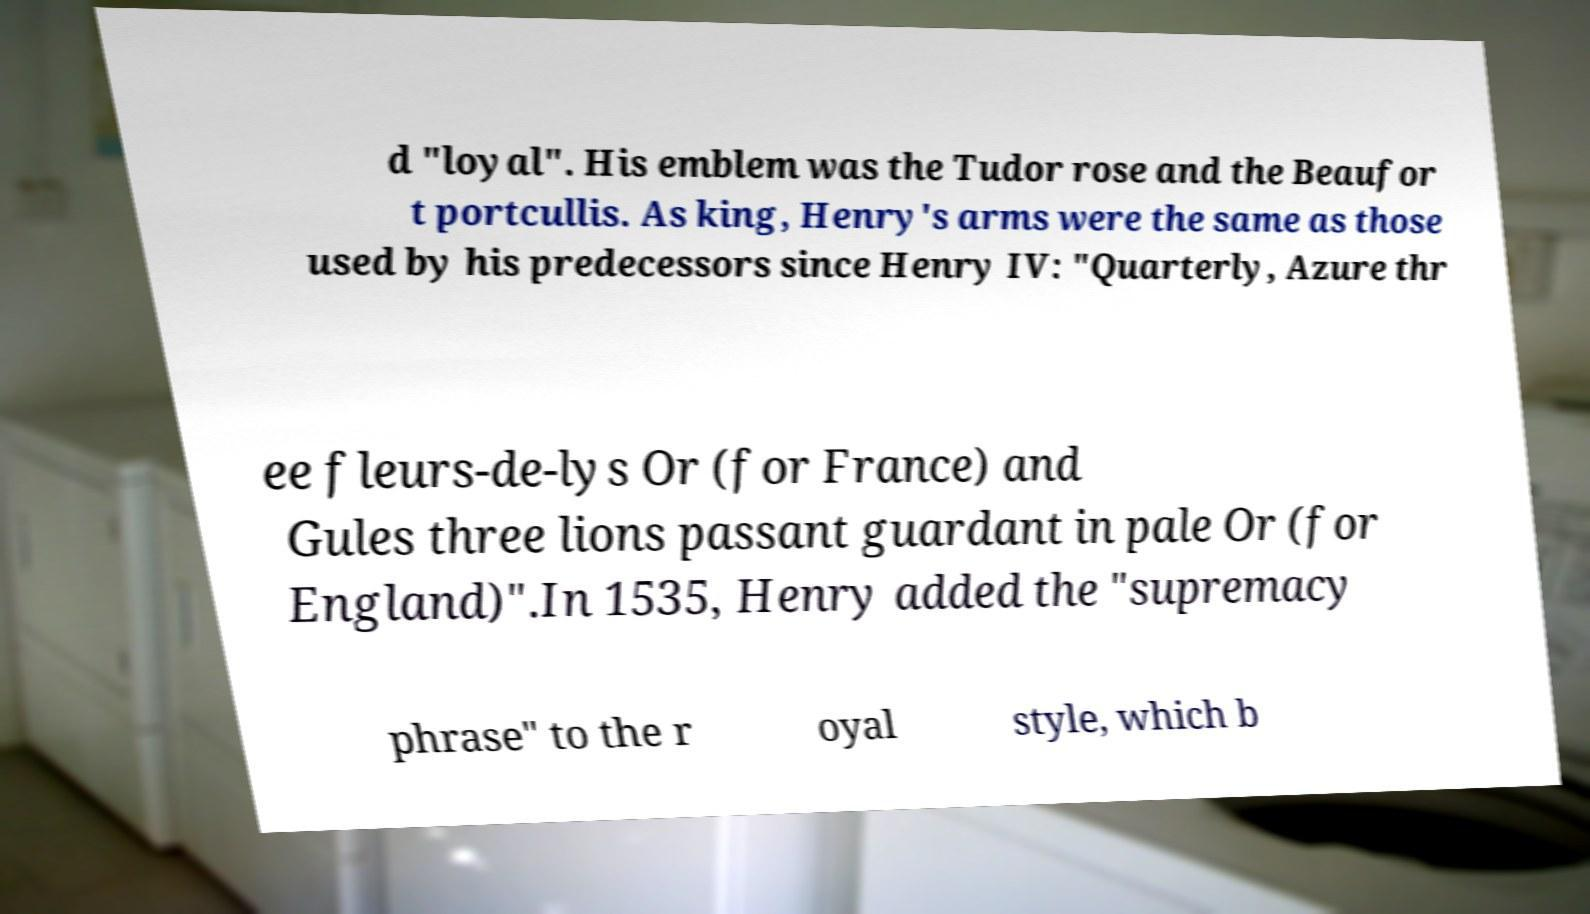There's text embedded in this image that I need extracted. Can you transcribe it verbatim? d "loyal". His emblem was the Tudor rose and the Beaufor t portcullis. As king, Henry's arms were the same as those used by his predecessors since Henry IV: "Quarterly, Azure thr ee fleurs-de-lys Or (for France) and Gules three lions passant guardant in pale Or (for England)".In 1535, Henry added the "supremacy phrase" to the r oyal style, which b 